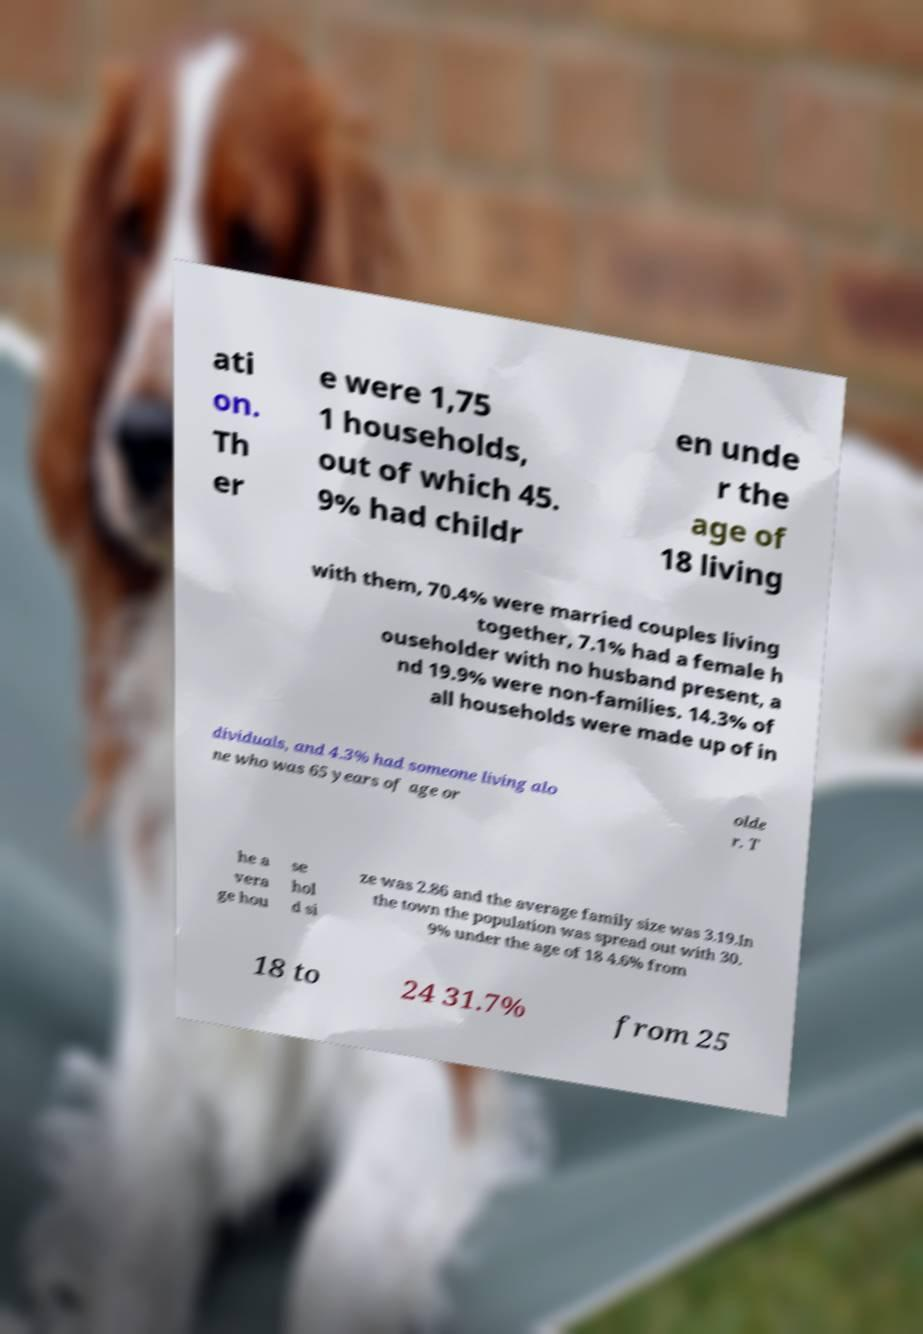There's text embedded in this image that I need extracted. Can you transcribe it verbatim? ati on. Th er e were 1,75 1 households, out of which 45. 9% had childr en unde r the age of 18 living with them, 70.4% were married couples living together, 7.1% had a female h ouseholder with no husband present, a nd 19.9% were non-families. 14.3% of all households were made up of in dividuals, and 4.3% had someone living alo ne who was 65 years of age or olde r. T he a vera ge hou se hol d si ze was 2.86 and the average family size was 3.19.In the town the population was spread out with 30. 9% under the age of 18 4.6% from 18 to 24 31.7% from 25 